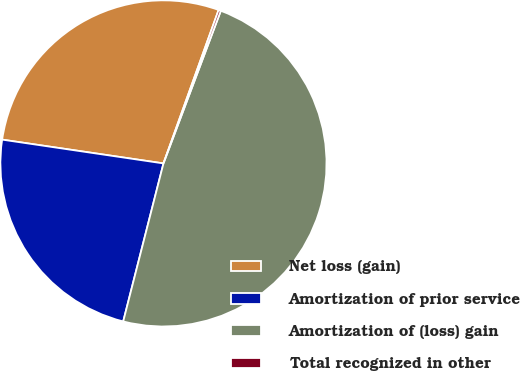Convert chart to OTSL. <chart><loc_0><loc_0><loc_500><loc_500><pie_chart><fcel>Net loss (gain)<fcel>Amortization of prior service<fcel>Amortization of (loss) gain<fcel>Total recognized in other<nl><fcel>28.16%<fcel>23.36%<fcel>48.25%<fcel>0.23%<nl></chart> 